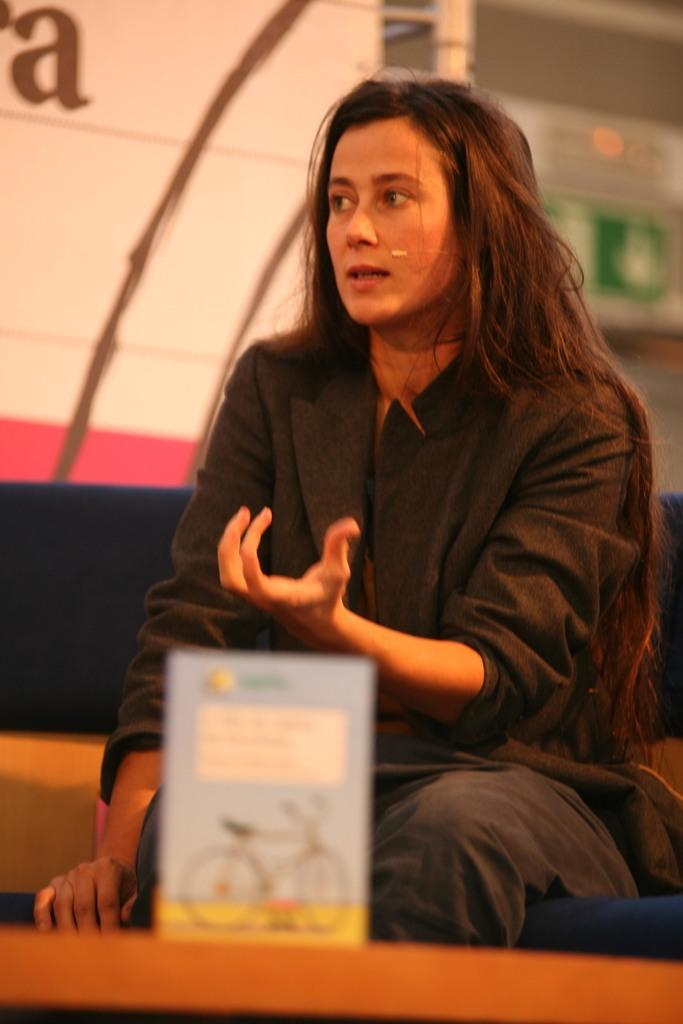What is the woman doing in the image? The woman is sitting in the image. What is the woman wearing? The woman is wearing a black dress. What can be seen in the image besides the woman? There is a board in the image. What colors are present on the board? The board has blue and yellow colors, and the background of the board has white and pink colors. How do the brothers feel about the loss in the image? There are no brothers or loss mentioned in the image; it only features a woman sitting and a board with colors. 